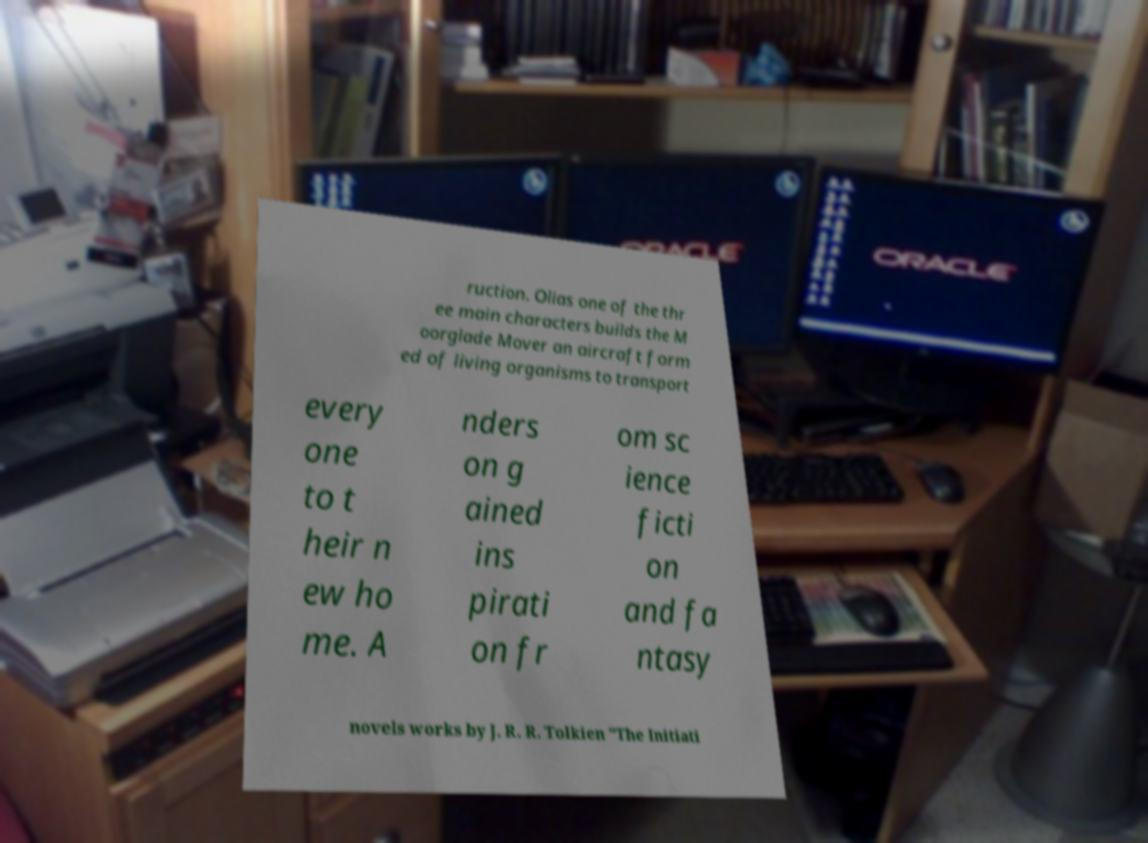There's text embedded in this image that I need extracted. Can you transcribe it verbatim? ruction. Olias one of the thr ee main characters builds the M oorglade Mover an aircraft form ed of living organisms to transport every one to t heir n ew ho me. A nders on g ained ins pirati on fr om sc ience ficti on and fa ntasy novels works by J. R. R. Tolkien "The Initiati 